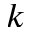Convert formula to latex. <formula><loc_0><loc_0><loc_500><loc_500>k</formula> 